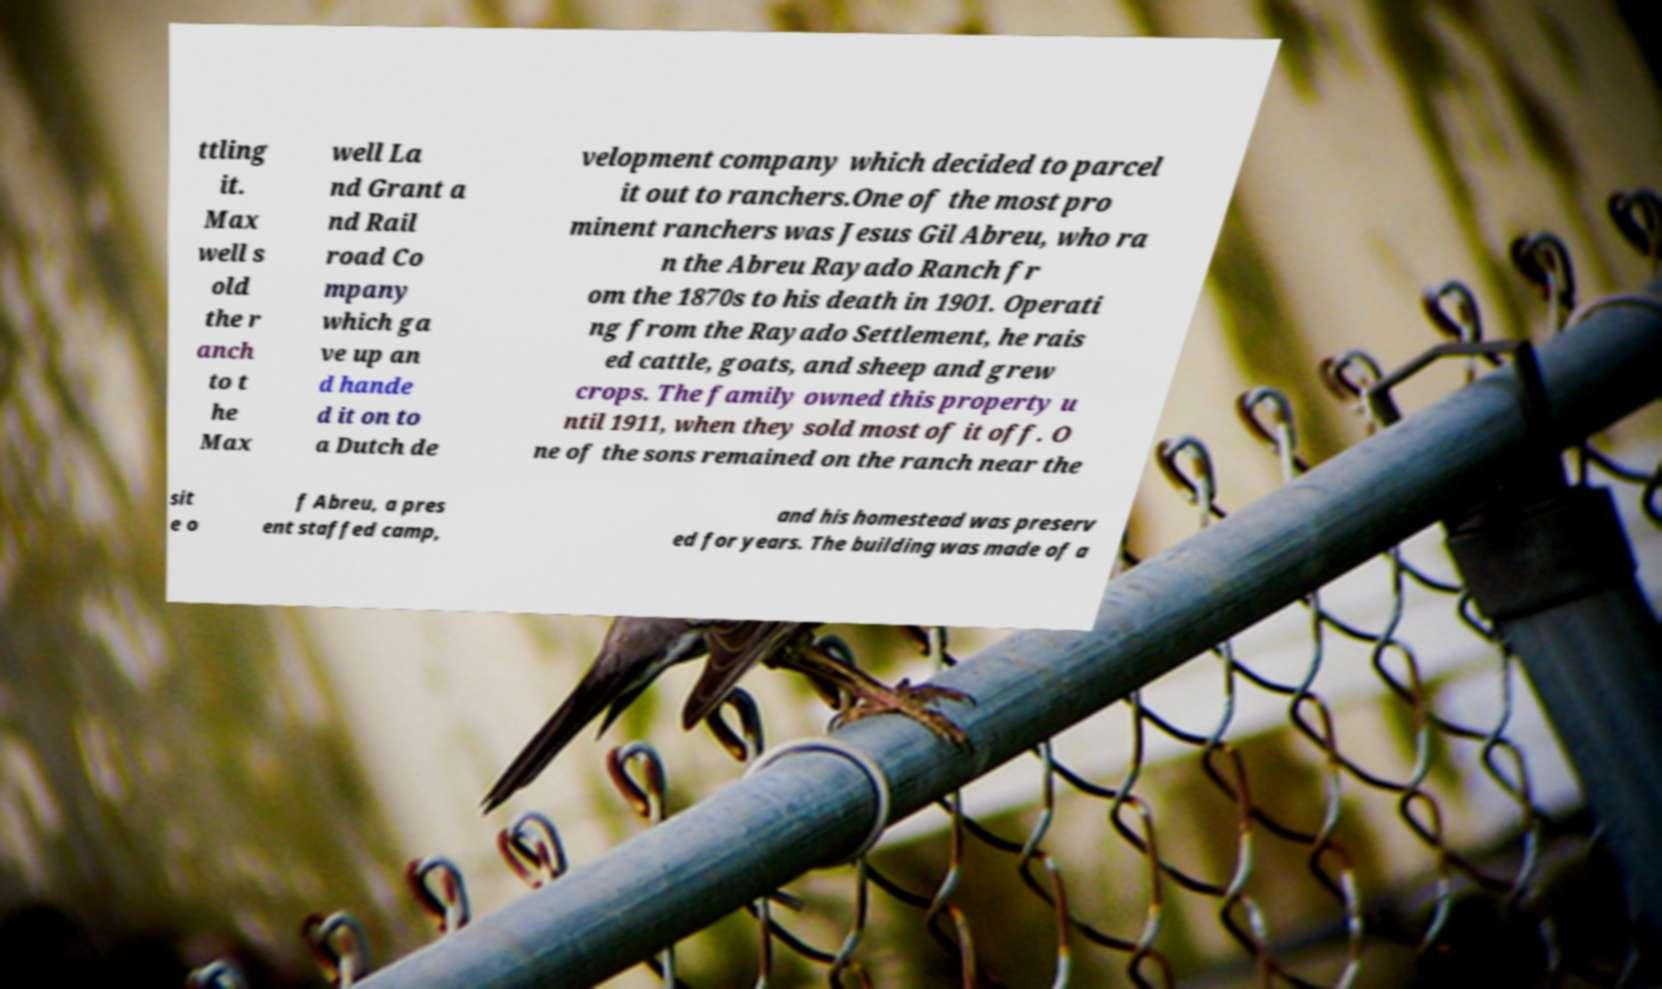Could you assist in decoding the text presented in this image and type it out clearly? ttling it. Max well s old the r anch to t he Max well La nd Grant a nd Rail road Co mpany which ga ve up an d hande d it on to a Dutch de velopment company which decided to parcel it out to ranchers.One of the most pro minent ranchers was Jesus Gil Abreu, who ra n the Abreu Rayado Ranch fr om the 1870s to his death in 1901. Operati ng from the Rayado Settlement, he rais ed cattle, goats, and sheep and grew crops. The family owned this property u ntil 1911, when they sold most of it off. O ne of the sons remained on the ranch near the sit e o f Abreu, a pres ent staffed camp, and his homestead was preserv ed for years. The building was made of a 